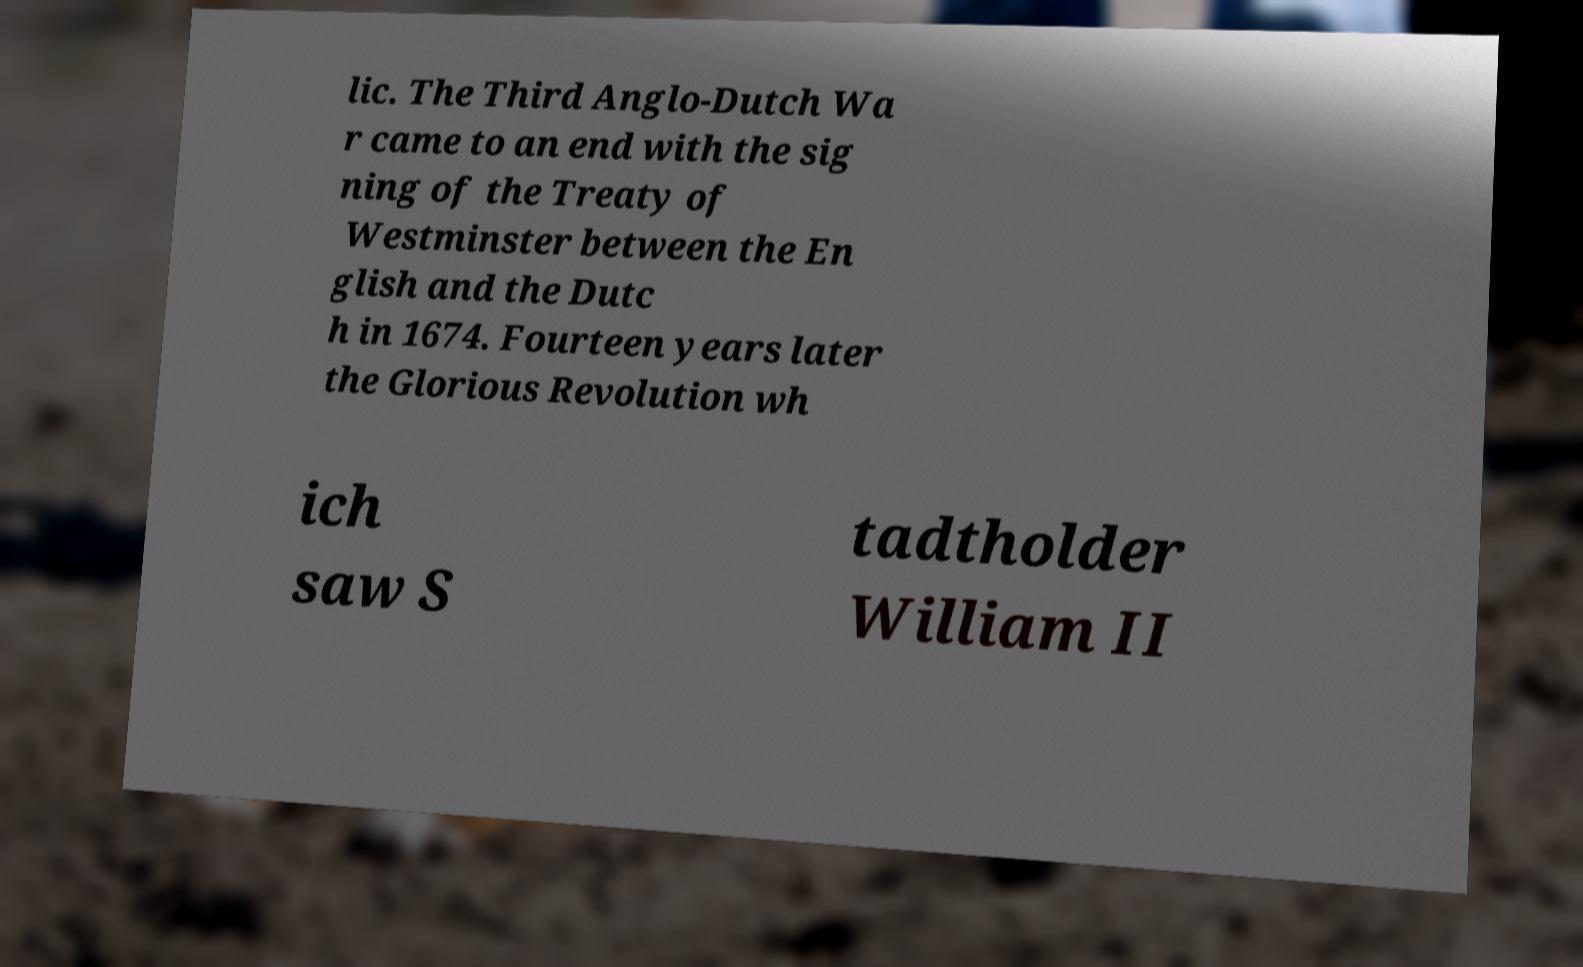For documentation purposes, I need the text within this image transcribed. Could you provide that? lic. The Third Anglo-Dutch Wa r came to an end with the sig ning of the Treaty of Westminster between the En glish and the Dutc h in 1674. Fourteen years later the Glorious Revolution wh ich saw S tadtholder William II 